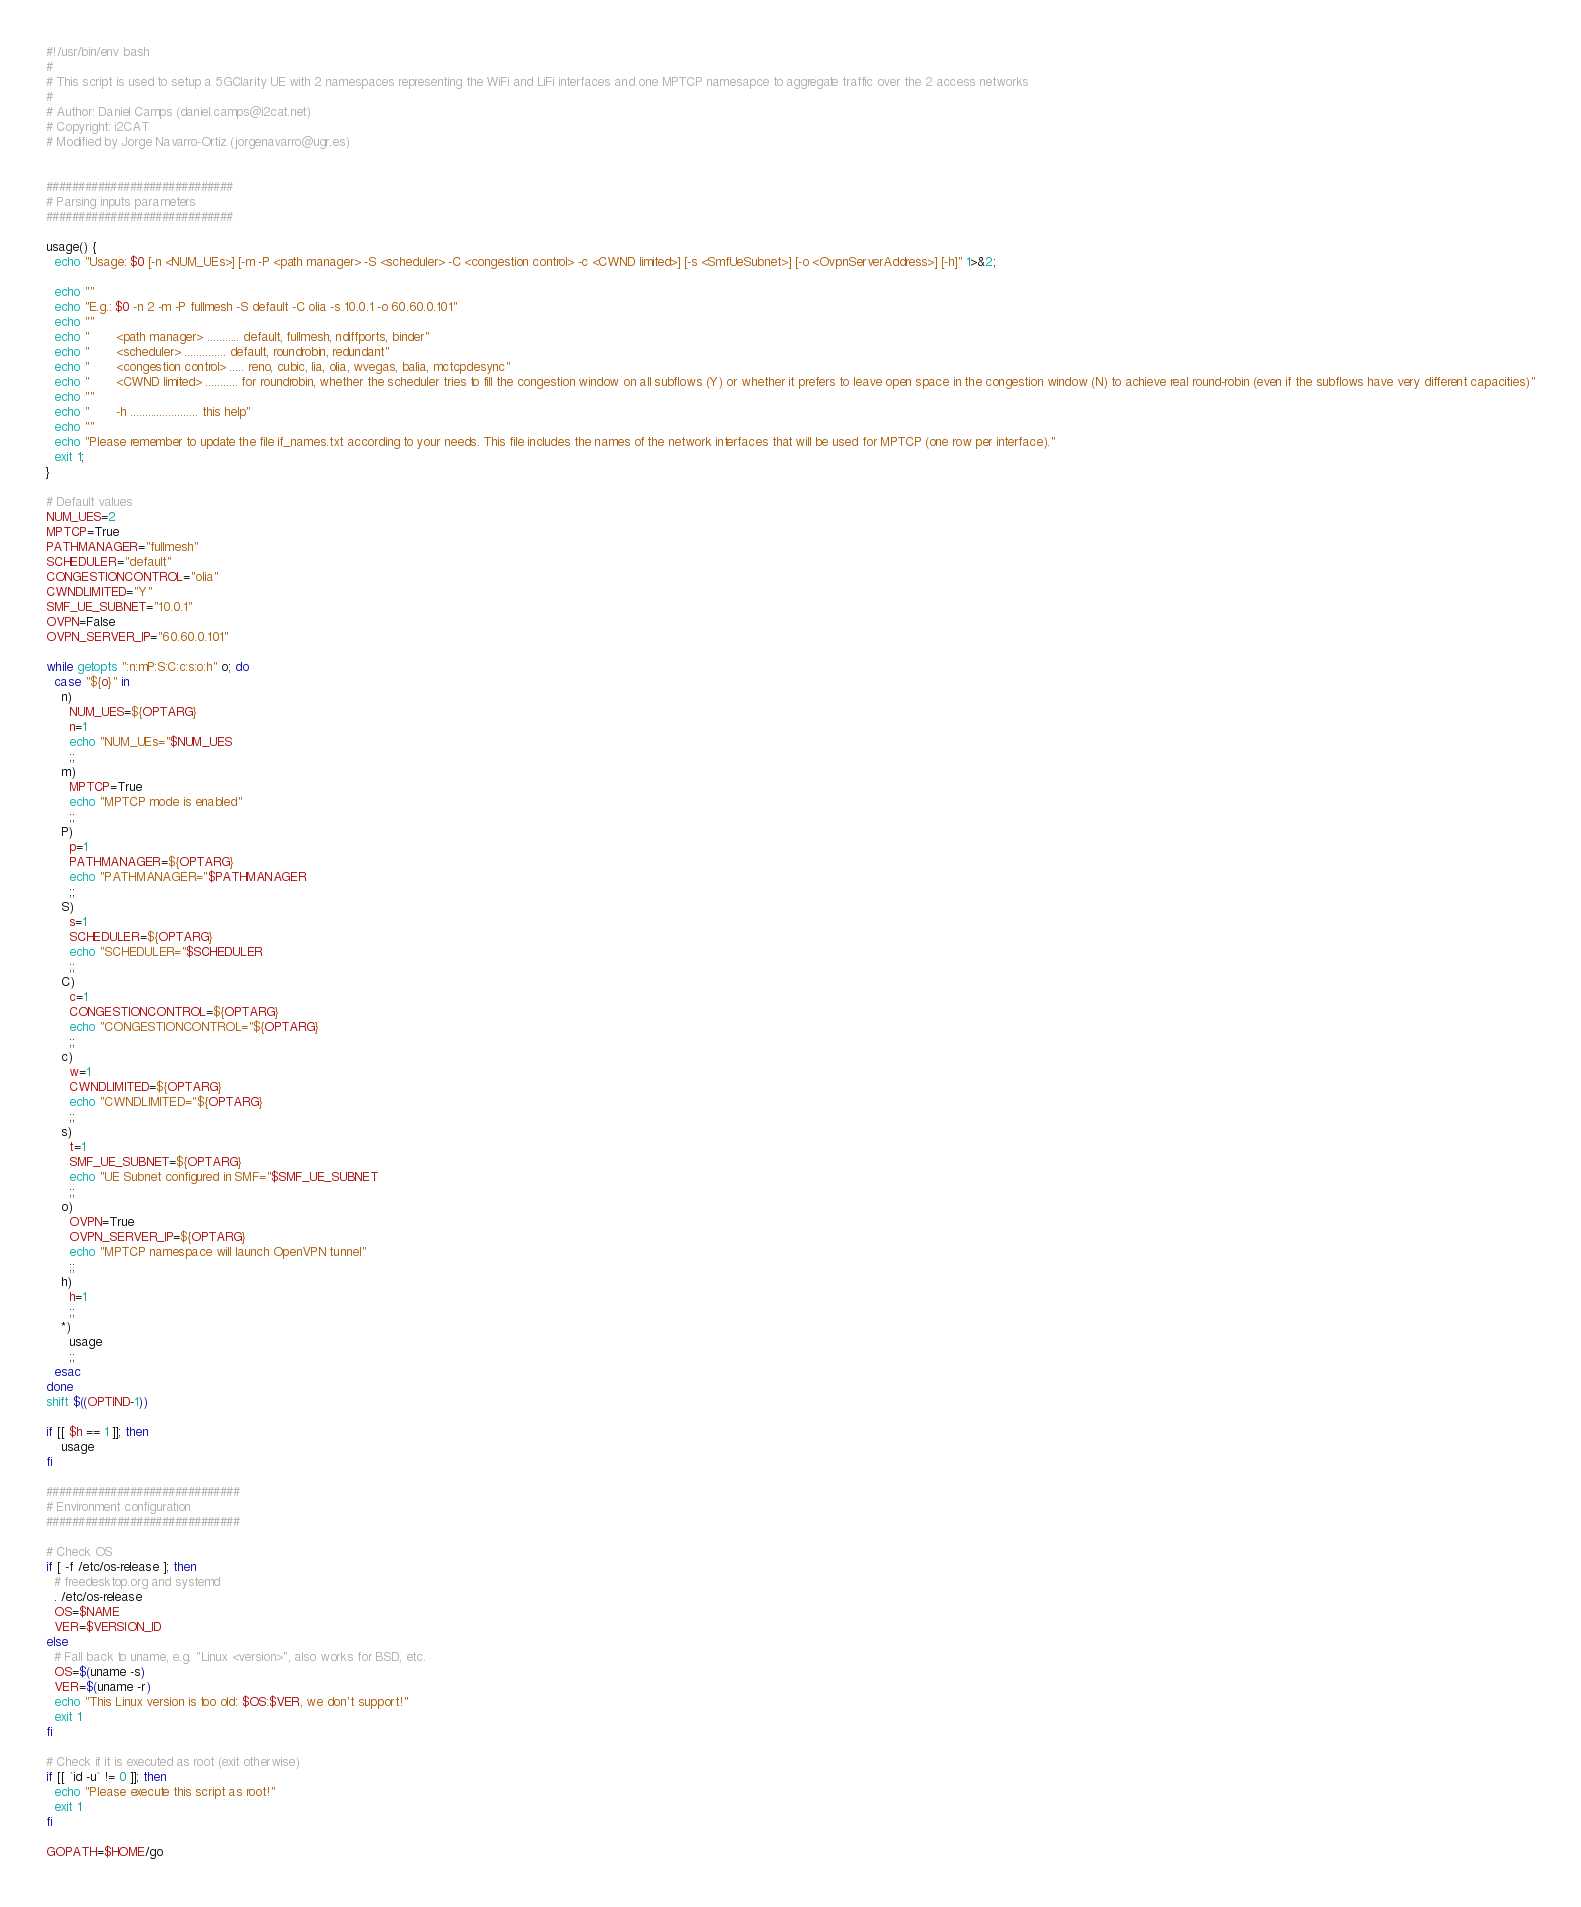<code> <loc_0><loc_0><loc_500><loc_500><_Bash_>#!/usr/bin/env bash
#
# This script is used to setup a 5GClarity UE with 2 namespaces representing the WiFi and LiFi interfaces and one MPTCP namesapce to aggregate traffic over the 2 access networks
#
# Author: Daniel Camps (daniel.camps@i2cat.net)
# Copyright: i2CAT
# Modified by Jorge Navarro-Ortiz (jorgenavarro@ugr.es)


#############################
# Parsing inputs parameters
#############################

usage() {
  echo "Usage: $0 [-n <NUM_UEs>] [-m -P <path manager> -S <scheduler> -C <congestion control> -c <CWND limited>] [-s <SmfUeSubnet>] [-o <OvpnServerAddress>] [-h]" 1>&2;

  echo ""
  echo "E.g.: $0 -n 2 -m -P fullmesh -S default -C olia -s 10.0.1 -o 60.60.0.101"
  echo ""
  echo "       <path manager> ........... default, fullmesh, ndiffports, binder"
  echo "       <scheduler> .............. default, roundrobin, redundant"
  echo "       <congestion control> ..... reno, cubic, lia, olia, wvegas, balia, mctcpdesync"
  echo "       <CWND limited> ........... for roundrobin, whether the scheduler tries to fill the congestion window on all subflows (Y) or whether it prefers to leave open space in the congestion window (N) to achieve real round-robin (even if the subflows have very different capacities)"
  echo ""
  echo "       -h ....................... this help"
  echo ""
  echo "Please remember to update the file if_names.txt according to your needs. This file includes the names of the network interfaces that will be used for MPTCP (one row per interface)."
  exit 1;
}

# Default values
NUM_UES=2
MPTCP=True
PATHMANAGER="fullmesh"
SCHEDULER="default"
CONGESTIONCONTROL="olia"
CWNDLIMITED="Y"
SMF_UE_SUBNET="10.0.1"
OVPN=False
OVPN_SERVER_IP="60.60.0.101"

while getopts ":n:mP:S:C:c:s:o:h" o; do
  case "${o}" in
    n)
      NUM_UES=${OPTARG}
      n=1
      echo "NUM_UEs="$NUM_UES
      ;;
    m)
      MPTCP=True
      echo "MPTCP mode is enabled"
      ;;
    P)
      p=1
      PATHMANAGER=${OPTARG}
      echo "PATHMANAGER="$PATHMANAGER
      ;;
    S)
      s=1
      SCHEDULER=${OPTARG}
      echo "SCHEDULER="$SCHEDULER
      ;;
    C)
      c=1
      CONGESTIONCONTROL=${OPTARG}
      echo "CONGESTIONCONTROL="${OPTARG}
      ;;
    c)
      w=1
      CWNDLIMITED=${OPTARG}
      echo "CWNDLIMITED="${OPTARG}
      ;;
    s)
      t=1
      SMF_UE_SUBNET=${OPTARG}
      echo "UE Subnet configured in SMF="$SMF_UE_SUBNET
      ;;
    o)
      OVPN=True
      OVPN_SERVER_IP=${OPTARG}
      echo "MPTCP namespace will launch OpenVPN tunnel"
      ;;
    h)
      h=1
      ;;
    *)
      usage
      ;;
  esac
done
shift $((OPTIND-1))

if [[ $h == 1 ]]; then
    usage
fi

##############################
# Environment configuration
##############################

# Check OS
if [ -f /etc/os-release ]; then
  # freedesktop.org and systemd
  . /etc/os-release
  OS=$NAME
  VER=$VERSION_ID
else
  # Fall back to uname, e.g. "Linux <version>", also works for BSD, etc.
  OS=$(uname -s)
  VER=$(uname -r)
  echo "This Linux version is too old: $OS:$VER, we don't support!"
  exit 1
fi

# Check if it is executed as root (exit otherwise)
if [[ `id -u` != 0 ]]; then
  echo "Please execute this script as root!"
  exit 1
fi

GOPATH=$HOME/go</code> 